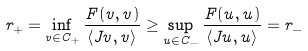<formula> <loc_0><loc_0><loc_500><loc_500>r _ { + } = \inf _ { v \in C _ { + } } \frac { F ( v , v ) } { \langle J v , v \rangle } \geq \sup _ { u \in C _ { - } } \frac { F ( u , u ) } { \langle J u , u \rangle } = r _ { - }</formula> 